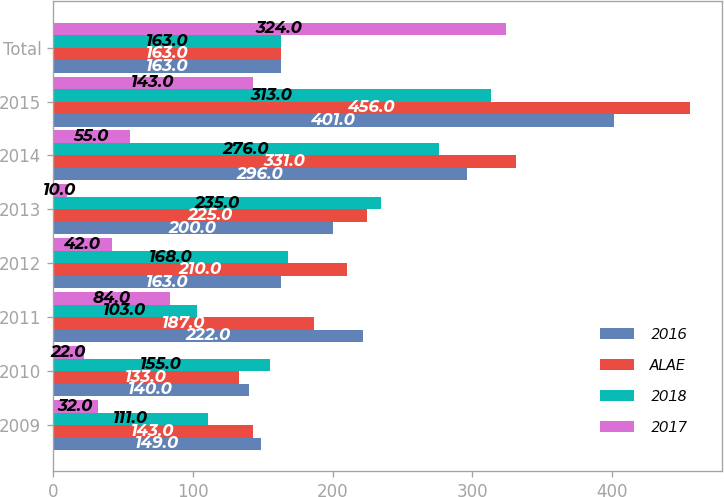Convert chart to OTSL. <chart><loc_0><loc_0><loc_500><loc_500><stacked_bar_chart><ecel><fcel>2009<fcel>2010<fcel>2011<fcel>2012<fcel>2013<fcel>2014<fcel>2015<fcel>Total<nl><fcel>2016<fcel>149<fcel>140<fcel>222<fcel>163<fcel>200<fcel>296<fcel>401<fcel>163<nl><fcel>ALAE<fcel>143<fcel>133<fcel>187<fcel>210<fcel>225<fcel>331<fcel>456<fcel>163<nl><fcel>2018<fcel>111<fcel>155<fcel>103<fcel>168<fcel>235<fcel>276<fcel>313<fcel>163<nl><fcel>2017<fcel>32<fcel>22<fcel>84<fcel>42<fcel>10<fcel>55<fcel>143<fcel>324<nl></chart> 